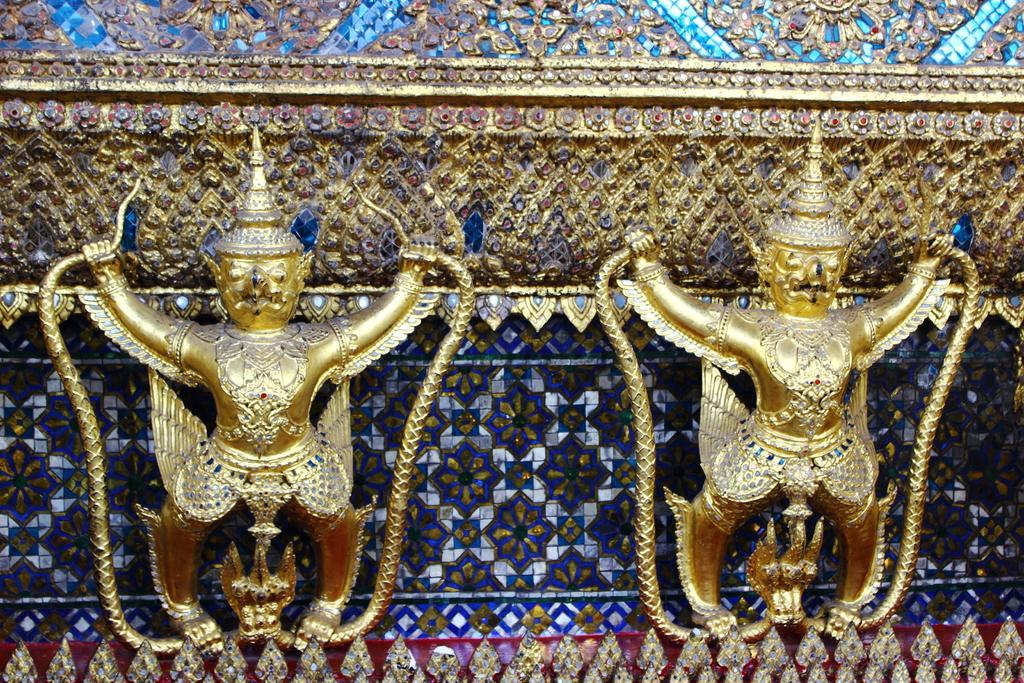In one or two sentences, can you explain what this image depicts? Here we can see two sculptures standing on a platform by holding an object. In the background we can see an object. 